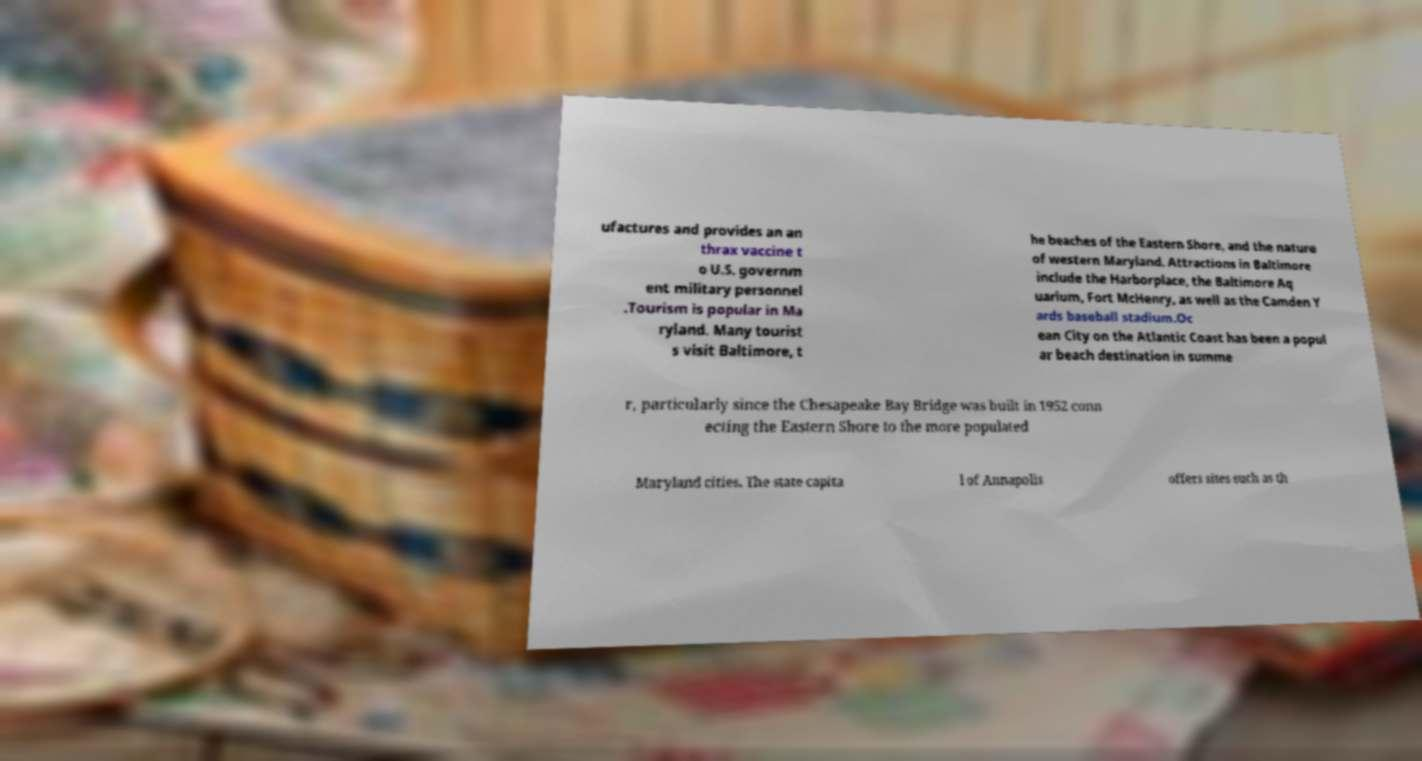Please read and relay the text visible in this image. What does it say? ufactures and provides an an thrax vaccine t o U.S. governm ent military personnel .Tourism is popular in Ma ryland. Many tourist s visit Baltimore, t he beaches of the Eastern Shore, and the nature of western Maryland. Attractions in Baltimore include the Harborplace, the Baltimore Aq uarium, Fort McHenry, as well as the Camden Y ards baseball stadium.Oc ean City on the Atlantic Coast has been a popul ar beach destination in summe r, particularly since the Chesapeake Bay Bridge was built in 1952 conn ecting the Eastern Shore to the more populated Maryland cities. The state capita l of Annapolis offers sites such as th 